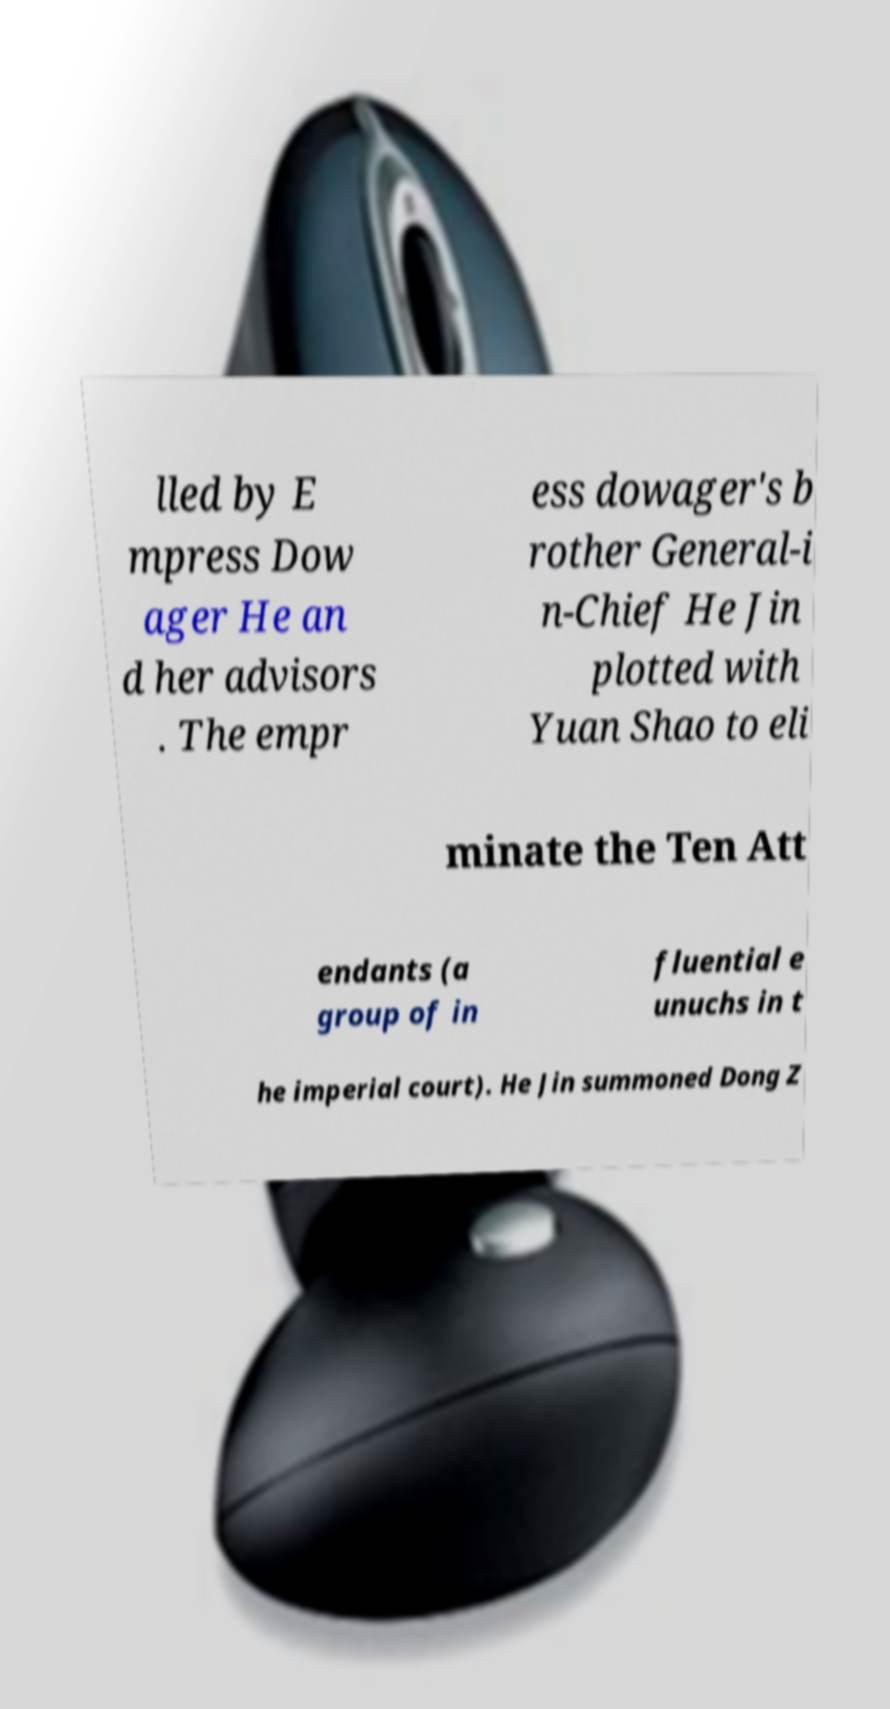Could you assist in decoding the text presented in this image and type it out clearly? lled by E mpress Dow ager He an d her advisors . The empr ess dowager's b rother General-i n-Chief He Jin plotted with Yuan Shao to eli minate the Ten Att endants (a group of in fluential e unuchs in t he imperial court). He Jin summoned Dong Z 